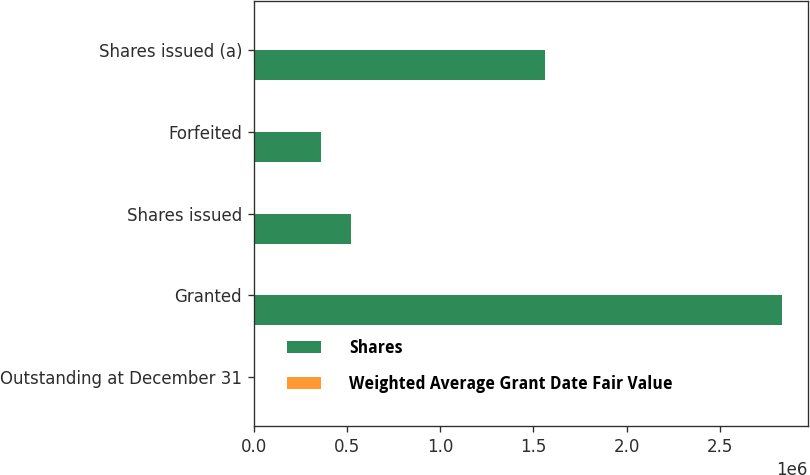Convert chart. <chart><loc_0><loc_0><loc_500><loc_500><stacked_bar_chart><ecel><fcel>Outstanding at December 31<fcel>Granted<fcel>Shares issued<fcel>Forfeited<fcel>Shares issued (a)<nl><fcel>Shares<fcel>42.55<fcel>2.83157e+06<fcel>519533<fcel>361965<fcel>1.56217e+06<nl><fcel>Weighted Average Grant Date Fair Value<fcel>35.67<fcel>41.56<fcel>40.68<fcel>41.81<fcel>42.55<nl></chart> 